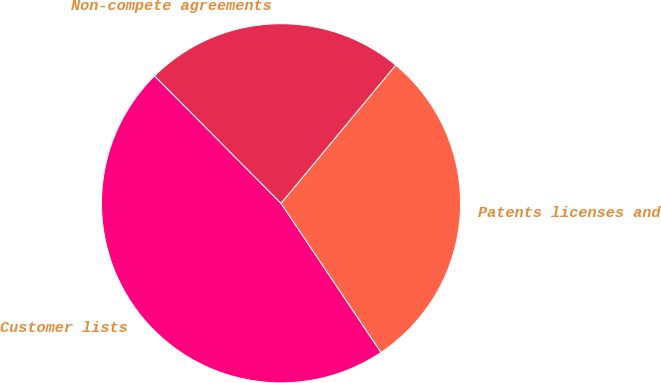Convert chart to OTSL. <chart><loc_0><loc_0><loc_500><loc_500><pie_chart><fcel>Customer lists<fcel>Patents licenses and<fcel>Non-compete agreements<nl><fcel>46.95%<fcel>29.58%<fcel>23.47%<nl></chart> 